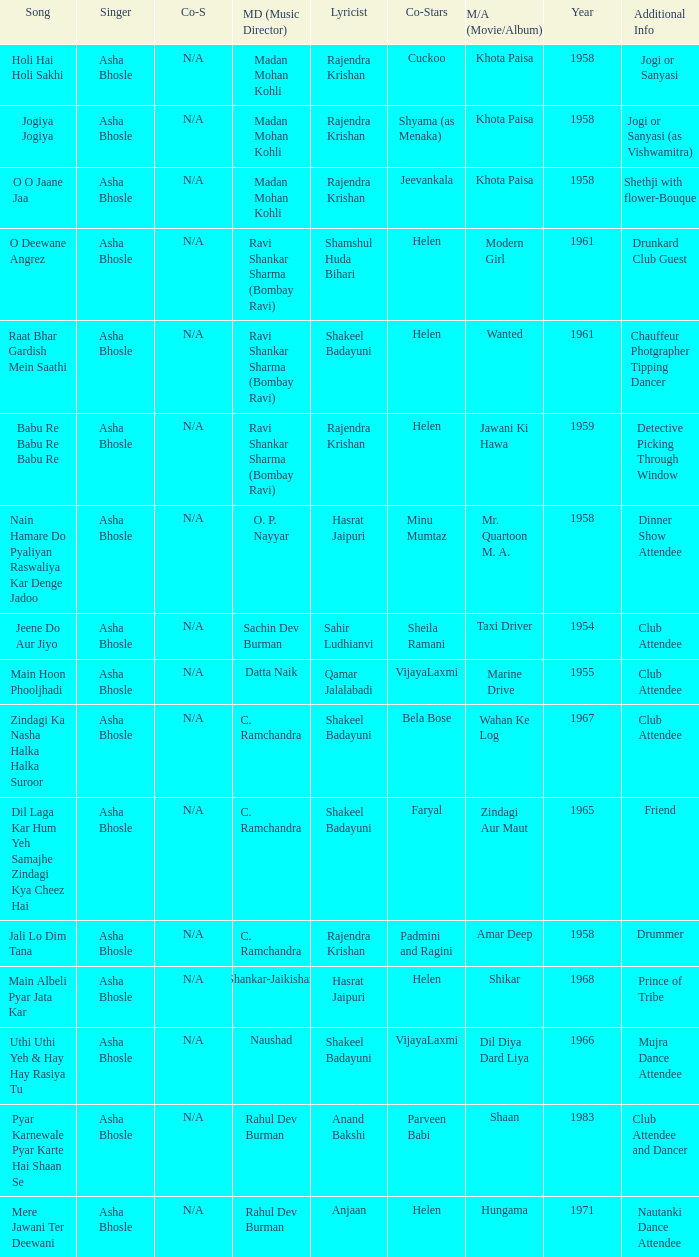What movie did Bela Bose co-star in? Wahan Ke Log. 